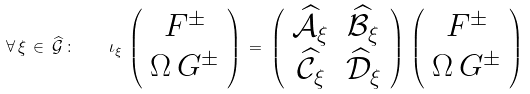Convert formula to latex. <formula><loc_0><loc_0><loc_500><loc_500>\forall \, \xi \, \in \, \widehat { \mathcal { G } } \, \colon \quad \iota _ { \xi } \, \left ( \begin{array} { c } F ^ { \pm } \\ \Omega \, G ^ { \pm } \end{array} \right ) \, = \, \left ( \begin{array} { c c } \widehat { \mathcal { A } } _ { \xi } & \widehat { \mathcal { B } } _ { \xi } \\ \widehat { \mathcal { C } } _ { \xi } & \widehat { \mathcal { D } } _ { \xi } \end{array} \right ) \, \left ( \begin{array} { c } F ^ { \pm } \\ \Omega \, G ^ { \pm } \end{array} \right )</formula> 